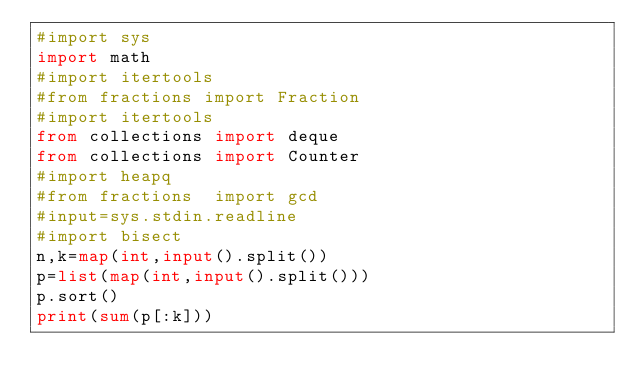<code> <loc_0><loc_0><loc_500><loc_500><_Python_>#import sys 
import math
#import itertools
#from fractions import Fraction
#import itertools
from collections import deque
from collections import Counter
#import heapq
#from fractions  import gcd
#input=sys.stdin.readline
#import bisect
n,k=map(int,input().split())
p=list(map(int,input().split()))
p.sort()
print(sum(p[:k]))</code> 